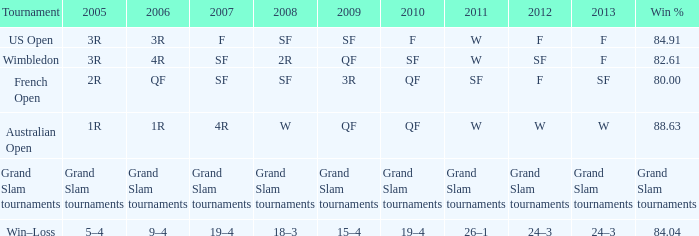Which competition had a 2007 record of 19 wins and 4 losses? Win–Loss. 